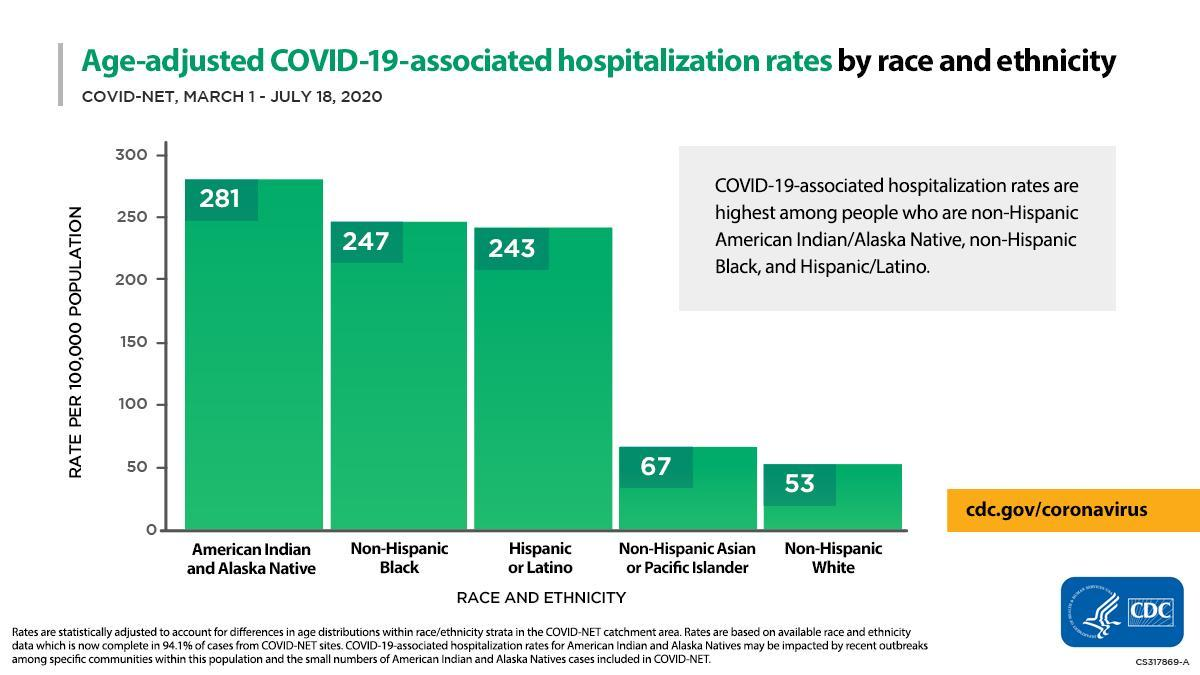What is the COVID-19-associated hospitalization rate (per 100,000 population) of non-hispanic blacks during March 1-July 18, 2020?
Answer the question with a short phrase. 247 Which ethnicity & race showed the highest COVID-19-associated hospitalization rate (per 100,000 population) during March 1-July 18, 2020? American Indian and Alaska Native What is the COVID-19-associated hospitalization rate (per 100,000 population) of non-hispanic whites during March 1-July 18, 2020? 53 Which ethnicity & race showed the lowest COVID-19-associated hospitalization rate (per 100,000 population) during March 1-July 18, 2020? Non-Hispanic White 